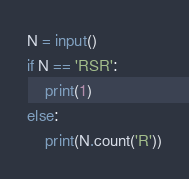<code> <loc_0><loc_0><loc_500><loc_500><_Python_>N = input()
if N == 'RSR':
    print(1)
else:
    print(N.count('R'))
</code> 